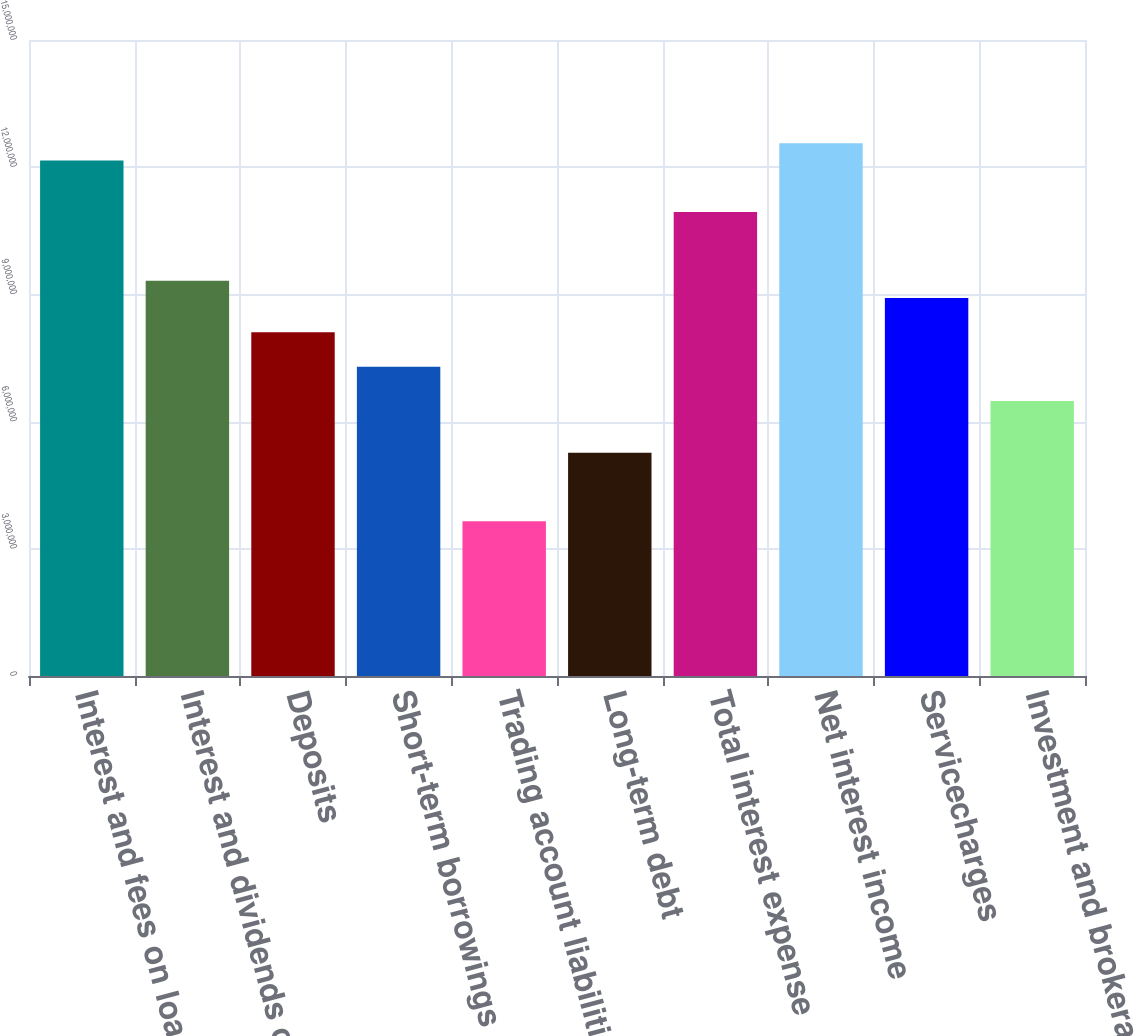Convert chart. <chart><loc_0><loc_0><loc_500><loc_500><bar_chart><fcel>Interest and fees on loans and<fcel>Interest and dividends on<fcel>Deposits<fcel>Short-term borrowings<fcel>Trading account liabilities<fcel>Long-term debt<fcel>Total interest expense<fcel>Net interest income<fcel>Servicecharges<fcel>Investment and brokerage<nl><fcel>1.21569e+07<fcel>9.3203e+06<fcel>8.10461e+06<fcel>7.29415e+06<fcel>3.64707e+06<fcel>5.268e+06<fcel>1.09412e+07<fcel>1.25621e+07<fcel>8.91507e+06<fcel>6.48369e+06<nl></chart> 